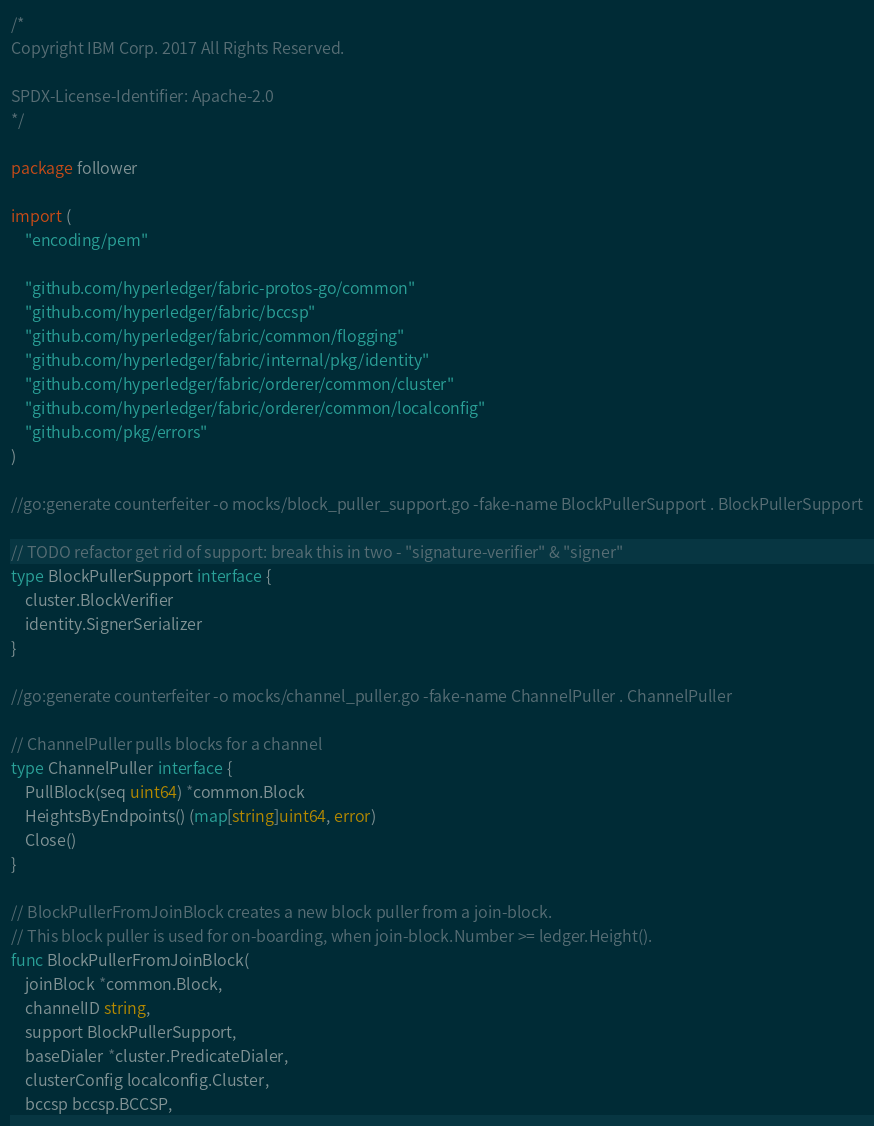<code> <loc_0><loc_0><loc_500><loc_500><_Go_>/*
Copyright IBM Corp. 2017 All Rights Reserved.

SPDX-License-Identifier: Apache-2.0
*/

package follower

import (
	"encoding/pem"

	"github.com/hyperledger/fabric-protos-go/common"
	"github.com/hyperledger/fabric/bccsp"
	"github.com/hyperledger/fabric/common/flogging"
	"github.com/hyperledger/fabric/internal/pkg/identity"
	"github.com/hyperledger/fabric/orderer/common/cluster"
	"github.com/hyperledger/fabric/orderer/common/localconfig"
	"github.com/pkg/errors"
)

//go:generate counterfeiter -o mocks/block_puller_support.go -fake-name BlockPullerSupport . BlockPullerSupport

// TODO refactor get rid of support: break this in two - "signature-verifier" & "signer"
type BlockPullerSupport interface {
	cluster.BlockVerifier
	identity.SignerSerializer
}

//go:generate counterfeiter -o mocks/channel_puller.go -fake-name ChannelPuller . ChannelPuller

// ChannelPuller pulls blocks for a channel
type ChannelPuller interface {
	PullBlock(seq uint64) *common.Block
	HeightsByEndpoints() (map[string]uint64, error)
	Close()
}

// BlockPullerFromJoinBlock creates a new block puller from a join-block.
// This block puller is used for on-boarding, when join-block.Number >= ledger.Height().
func BlockPullerFromJoinBlock(
	joinBlock *common.Block,
	channelID string,
	support BlockPullerSupport,
	baseDialer *cluster.PredicateDialer,
	clusterConfig localconfig.Cluster,
	bccsp bccsp.BCCSP,</code> 